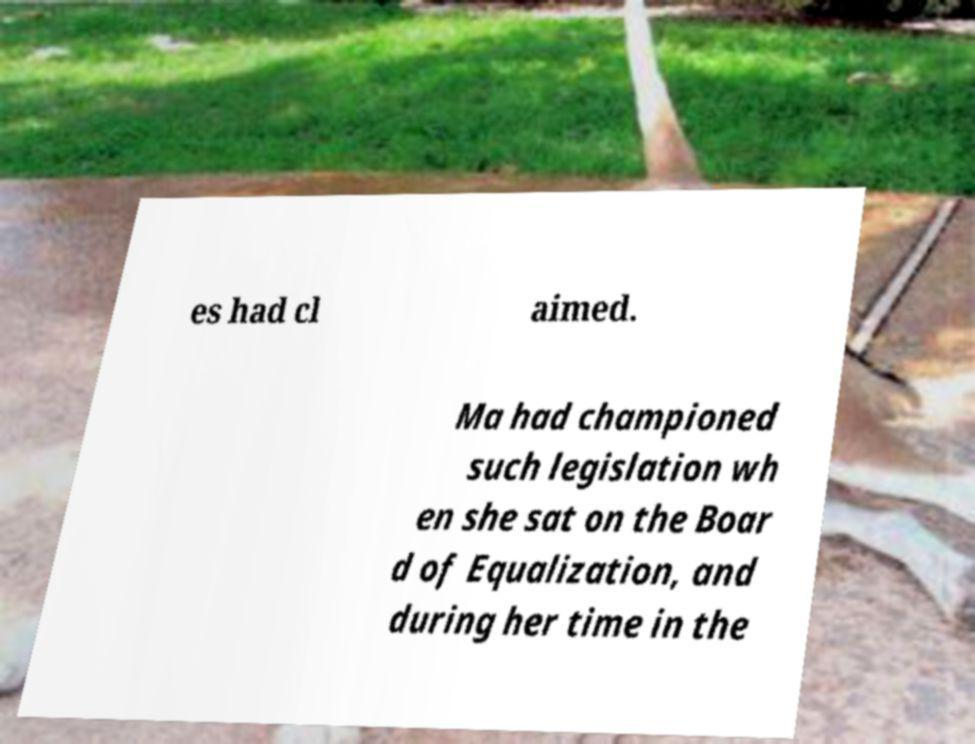There's text embedded in this image that I need extracted. Can you transcribe it verbatim? es had cl aimed. Ma had championed such legislation wh en she sat on the Boar d of Equalization, and during her time in the 